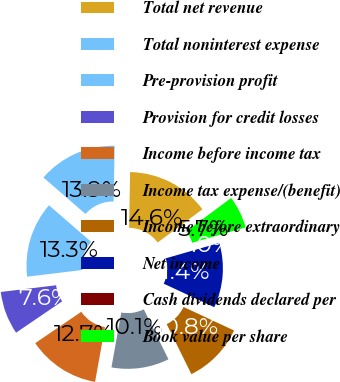Convert chart. <chart><loc_0><loc_0><loc_500><loc_500><pie_chart><fcel>Total net revenue<fcel>Total noninterest expense<fcel>Pre-provision profit<fcel>Provision for credit losses<fcel>Income before income tax<fcel>Income tax expense/(benefit)<fcel>Income before extraordinary<fcel>Net income<fcel>Cash dividends declared per<fcel>Book value per share<nl><fcel>14.56%<fcel>13.92%<fcel>13.29%<fcel>7.59%<fcel>12.66%<fcel>10.13%<fcel>10.76%<fcel>11.39%<fcel>0.0%<fcel>5.7%<nl></chart> 